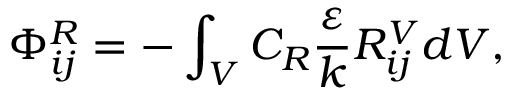<formula> <loc_0><loc_0><loc_500><loc_500>\Phi _ { i j } ^ { R } = - \int _ { V } C _ { R } \frac { \varepsilon } { k } R _ { i j } ^ { V } d V ,</formula> 